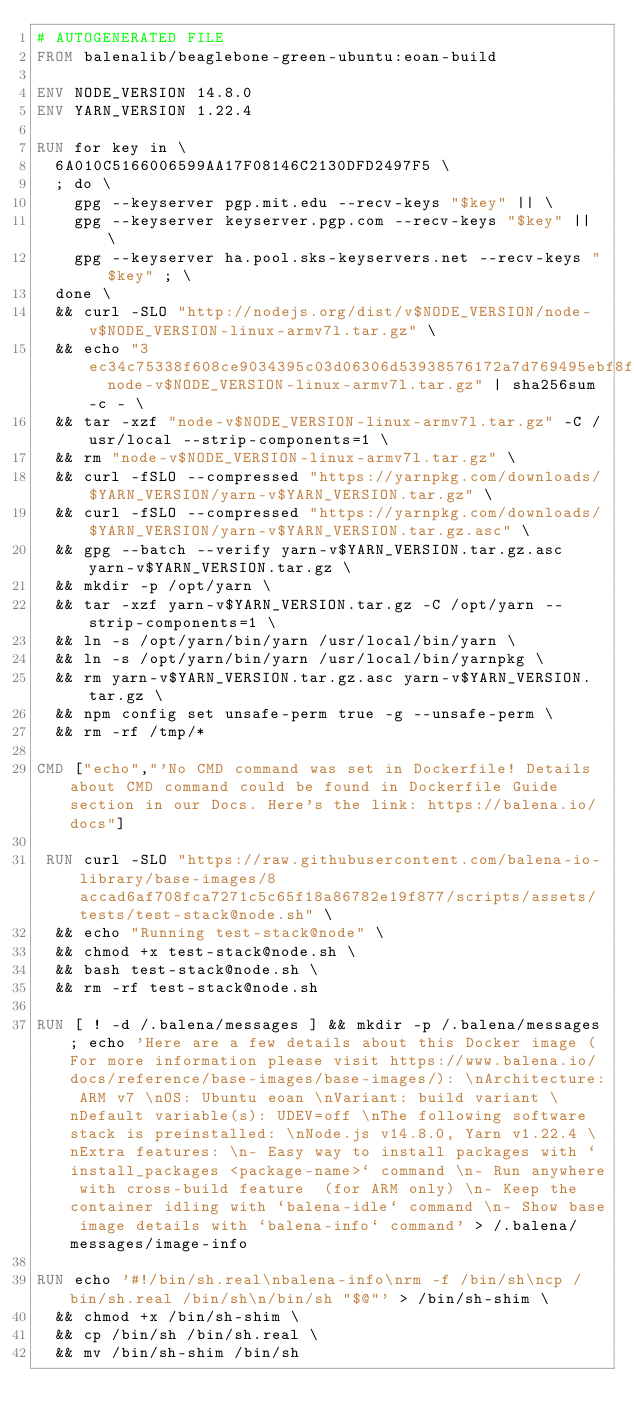<code> <loc_0><loc_0><loc_500><loc_500><_Dockerfile_># AUTOGENERATED FILE
FROM balenalib/beaglebone-green-ubuntu:eoan-build

ENV NODE_VERSION 14.8.0
ENV YARN_VERSION 1.22.4

RUN for key in \
	6A010C5166006599AA17F08146C2130DFD2497F5 \
	; do \
		gpg --keyserver pgp.mit.edu --recv-keys "$key" || \
		gpg --keyserver keyserver.pgp.com --recv-keys "$key" || \
		gpg --keyserver ha.pool.sks-keyservers.net --recv-keys "$key" ; \
	done \
	&& curl -SLO "http://nodejs.org/dist/v$NODE_VERSION/node-v$NODE_VERSION-linux-armv7l.tar.gz" \
	&& echo "3ec34c75338f608ce9034395c03d06306d53938576172a7d769495ebf8ff512b  node-v$NODE_VERSION-linux-armv7l.tar.gz" | sha256sum -c - \
	&& tar -xzf "node-v$NODE_VERSION-linux-armv7l.tar.gz" -C /usr/local --strip-components=1 \
	&& rm "node-v$NODE_VERSION-linux-armv7l.tar.gz" \
	&& curl -fSLO --compressed "https://yarnpkg.com/downloads/$YARN_VERSION/yarn-v$YARN_VERSION.tar.gz" \
	&& curl -fSLO --compressed "https://yarnpkg.com/downloads/$YARN_VERSION/yarn-v$YARN_VERSION.tar.gz.asc" \
	&& gpg --batch --verify yarn-v$YARN_VERSION.tar.gz.asc yarn-v$YARN_VERSION.tar.gz \
	&& mkdir -p /opt/yarn \
	&& tar -xzf yarn-v$YARN_VERSION.tar.gz -C /opt/yarn --strip-components=1 \
	&& ln -s /opt/yarn/bin/yarn /usr/local/bin/yarn \
	&& ln -s /opt/yarn/bin/yarn /usr/local/bin/yarnpkg \
	&& rm yarn-v$YARN_VERSION.tar.gz.asc yarn-v$YARN_VERSION.tar.gz \
	&& npm config set unsafe-perm true -g --unsafe-perm \
	&& rm -rf /tmp/*

CMD ["echo","'No CMD command was set in Dockerfile! Details about CMD command could be found in Dockerfile Guide section in our Docs. Here's the link: https://balena.io/docs"]

 RUN curl -SLO "https://raw.githubusercontent.com/balena-io-library/base-images/8accad6af708fca7271c5c65f18a86782e19f877/scripts/assets/tests/test-stack@node.sh" \
  && echo "Running test-stack@node" \
  && chmod +x test-stack@node.sh \
  && bash test-stack@node.sh \
  && rm -rf test-stack@node.sh 

RUN [ ! -d /.balena/messages ] && mkdir -p /.balena/messages; echo 'Here are a few details about this Docker image (For more information please visit https://www.balena.io/docs/reference/base-images/base-images/): \nArchitecture: ARM v7 \nOS: Ubuntu eoan \nVariant: build variant \nDefault variable(s): UDEV=off \nThe following software stack is preinstalled: \nNode.js v14.8.0, Yarn v1.22.4 \nExtra features: \n- Easy way to install packages with `install_packages <package-name>` command \n- Run anywhere with cross-build feature  (for ARM only) \n- Keep the container idling with `balena-idle` command \n- Show base image details with `balena-info` command' > /.balena/messages/image-info

RUN echo '#!/bin/sh.real\nbalena-info\nrm -f /bin/sh\ncp /bin/sh.real /bin/sh\n/bin/sh "$@"' > /bin/sh-shim \
	&& chmod +x /bin/sh-shim \
	&& cp /bin/sh /bin/sh.real \
	&& mv /bin/sh-shim /bin/sh</code> 